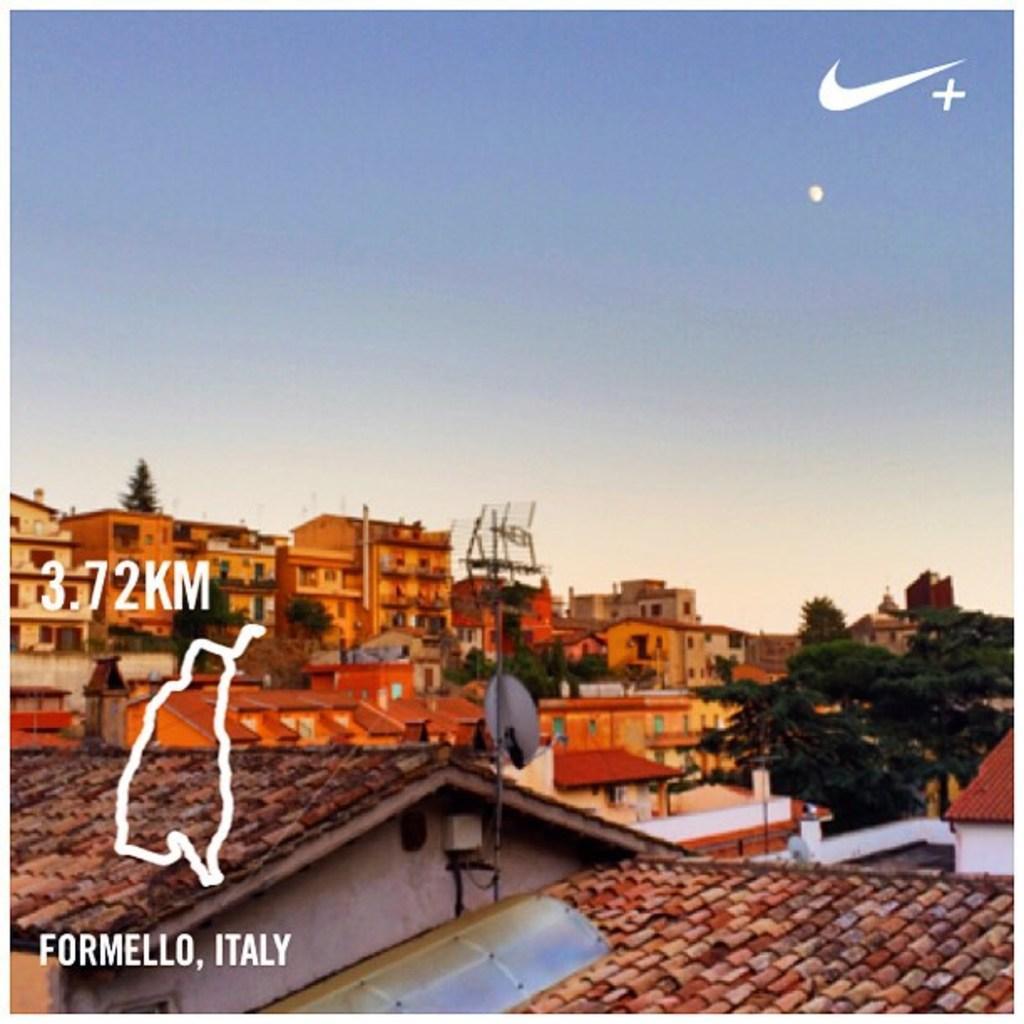How would you summarize this image in a sentence or two? At the bottom of this image I can see many buildings and trees. On the left side there is some edited text. At the top of the image I can see the sky in blue color. 